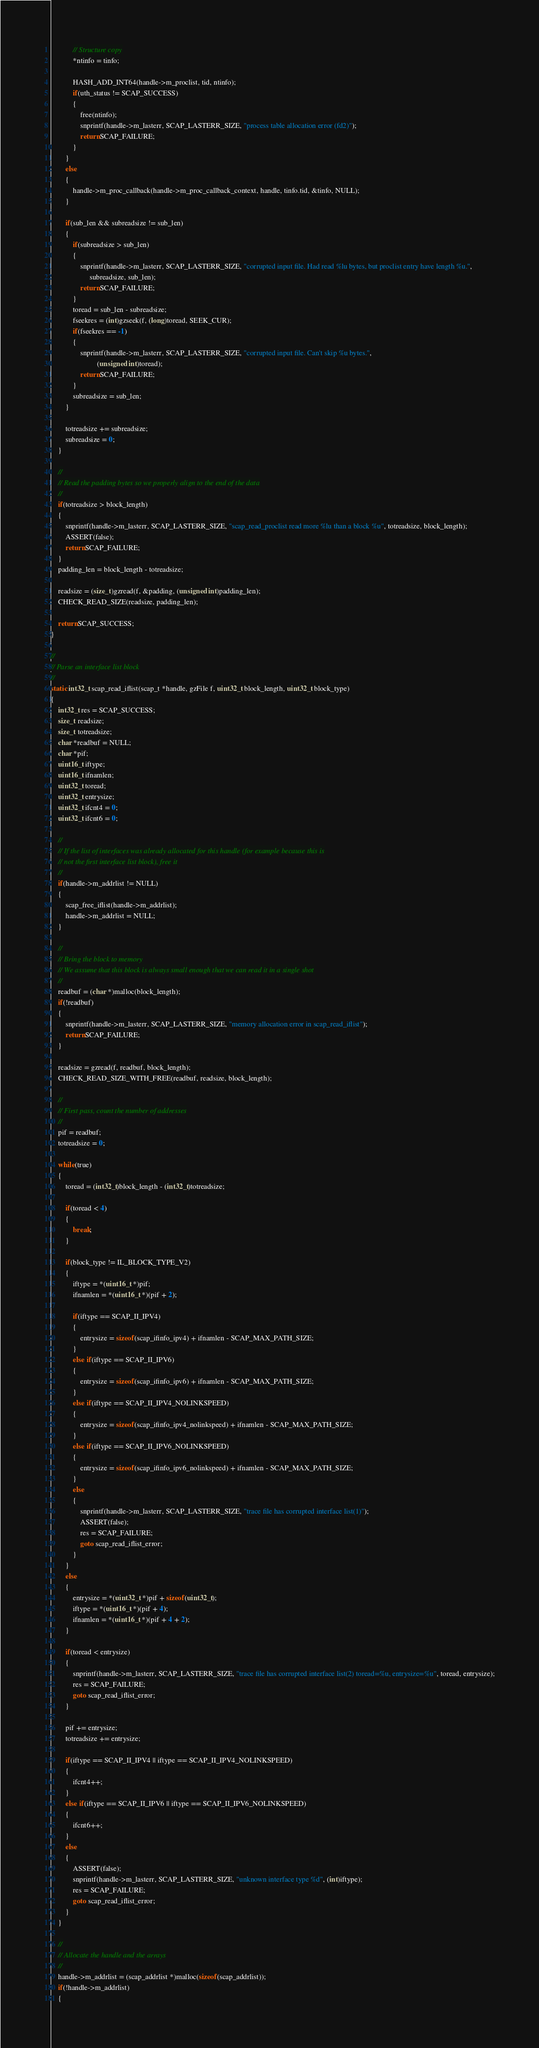Convert code to text. <code><loc_0><loc_0><loc_500><loc_500><_C_>
			// Structure copy
			*ntinfo = tinfo;

			HASH_ADD_INT64(handle->m_proclist, tid, ntinfo);
			if(uth_status != SCAP_SUCCESS)
			{
				free(ntinfo);
				snprintf(handle->m_lasterr, SCAP_LASTERR_SIZE, "process table allocation error (fd2)");
				return SCAP_FAILURE;
			}
		}
		else
		{
			handle->m_proc_callback(handle->m_proc_callback_context, handle, tinfo.tid, &tinfo, NULL);
		}

		if(sub_len && subreadsize != sub_len)
		{
			if(subreadsize > sub_len)
			{
				snprintf(handle->m_lasterr, SCAP_LASTERR_SIZE, "corrupted input file. Had read %lu bytes, but proclist entry have length %u.",
					 subreadsize, sub_len);
				return SCAP_FAILURE;
			}
			toread = sub_len - subreadsize;
			fseekres = (int)gzseek(f, (long)toread, SEEK_CUR);
			if(fseekres == -1)
			{
				snprintf(handle->m_lasterr, SCAP_LASTERR_SIZE, "corrupted input file. Can't skip %u bytes.",
				         (unsigned int)toread);
				return SCAP_FAILURE;
			}
			subreadsize = sub_len;
		}

		totreadsize += subreadsize;
		subreadsize = 0;
	}

	//
	// Read the padding bytes so we properly align to the end of the data
	//
	if(totreadsize > block_length)
	{
		snprintf(handle->m_lasterr, SCAP_LASTERR_SIZE, "scap_read_proclist read more %lu than a block %u", totreadsize, block_length);
		ASSERT(false);
		return SCAP_FAILURE;
	}
	padding_len = block_length - totreadsize;

	readsize = (size_t)gzread(f, &padding, (unsigned int)padding_len);
	CHECK_READ_SIZE(readsize, padding_len);

	return SCAP_SUCCESS;
}

//
// Parse an interface list block
//
static int32_t scap_read_iflist(scap_t *handle, gzFile f, uint32_t block_length, uint32_t block_type)
{
	int32_t res = SCAP_SUCCESS;
	size_t readsize;
	size_t totreadsize;
	char *readbuf = NULL;
	char *pif;
	uint16_t iftype;
	uint16_t ifnamlen;
	uint32_t toread;
	uint32_t entrysize;
	uint32_t ifcnt4 = 0;
	uint32_t ifcnt6 = 0;

	//
	// If the list of interfaces was already allocated for this handle (for example because this is
	// not the first interface list block), free it
	//
	if(handle->m_addrlist != NULL)
	{
		scap_free_iflist(handle->m_addrlist);
		handle->m_addrlist = NULL;
	}

	//
	// Bring the block to memory
	// We assume that this block is always small enough that we can read it in a single shot
	//
	readbuf = (char *)malloc(block_length);
	if(!readbuf)
	{
		snprintf(handle->m_lasterr, SCAP_LASTERR_SIZE, "memory allocation error in scap_read_iflist");
		return SCAP_FAILURE;
	}

	readsize = gzread(f, readbuf, block_length);
	CHECK_READ_SIZE_WITH_FREE(readbuf, readsize, block_length);

	//
	// First pass, count the number of addresses
	//
	pif = readbuf;
	totreadsize = 0;

	while(true)
	{
		toread = (int32_t)block_length - (int32_t)totreadsize;

		if(toread < 4)
		{
			break;
		}

		if(block_type != IL_BLOCK_TYPE_V2)
		{
			iftype = *(uint16_t *)pif;
			ifnamlen = *(uint16_t *)(pif + 2);

			if(iftype == SCAP_II_IPV4)
			{
				entrysize = sizeof(scap_ifinfo_ipv4) + ifnamlen - SCAP_MAX_PATH_SIZE;
			}
			else if(iftype == SCAP_II_IPV6)
			{
				entrysize = sizeof(scap_ifinfo_ipv6) + ifnamlen - SCAP_MAX_PATH_SIZE;
			}
			else if(iftype == SCAP_II_IPV4_NOLINKSPEED)
			{
				entrysize = sizeof(scap_ifinfo_ipv4_nolinkspeed) + ifnamlen - SCAP_MAX_PATH_SIZE;
			}
			else if(iftype == SCAP_II_IPV6_NOLINKSPEED)
			{
				entrysize = sizeof(scap_ifinfo_ipv6_nolinkspeed) + ifnamlen - SCAP_MAX_PATH_SIZE;
			}
			else
			{
				snprintf(handle->m_lasterr, SCAP_LASTERR_SIZE, "trace file has corrupted interface list(1)");
				ASSERT(false);
				res = SCAP_FAILURE;
				goto scap_read_iflist_error;
			}
		}
		else
		{
			entrysize = *(uint32_t *)pif + sizeof(uint32_t);
			iftype = *(uint16_t *)(pif + 4);
			ifnamlen = *(uint16_t *)(pif + 4 + 2);
		}

		if(toread < entrysize)
		{
			snprintf(handle->m_lasterr, SCAP_LASTERR_SIZE, "trace file has corrupted interface list(2) toread=%u, entrysize=%u", toread, entrysize);
			res = SCAP_FAILURE;
			goto scap_read_iflist_error;
		}

		pif += entrysize;
		totreadsize += entrysize;

		if(iftype == SCAP_II_IPV4 || iftype == SCAP_II_IPV4_NOLINKSPEED)
		{
			ifcnt4++;
		}
		else if(iftype == SCAP_II_IPV6 || iftype == SCAP_II_IPV6_NOLINKSPEED)
		{
			ifcnt6++;
		}
		else
		{
			ASSERT(false);
			snprintf(handle->m_lasterr, SCAP_LASTERR_SIZE, "unknown interface type %d", (int)iftype);
			res = SCAP_FAILURE;
			goto scap_read_iflist_error;
		}
	}

	//
	// Allocate the handle and the arrays
	//
	handle->m_addrlist = (scap_addrlist *)malloc(sizeof(scap_addrlist));
	if(!handle->m_addrlist)
	{</code> 